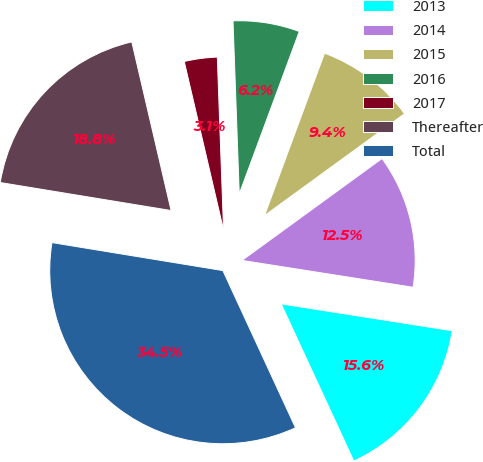Convert chart to OTSL. <chart><loc_0><loc_0><loc_500><loc_500><pie_chart><fcel>2013<fcel>2014<fcel>2015<fcel>2016<fcel>2017<fcel>Thereafter<fcel>Total<nl><fcel>15.63%<fcel>12.49%<fcel>9.35%<fcel>6.21%<fcel>3.07%<fcel>18.77%<fcel>34.47%<nl></chart> 